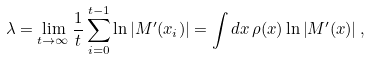<formula> <loc_0><loc_0><loc_500><loc_500>\lambda = \lim _ { t \rightarrow \infty } \frac { 1 } { t } \sum _ { i = 0 } ^ { t - 1 } \ln \left | M ^ { \prime } ( x _ { i } ) \right | = \int d x \, \rho ( x ) \ln \left | M ^ { \prime } ( x ) \right | ,</formula> 